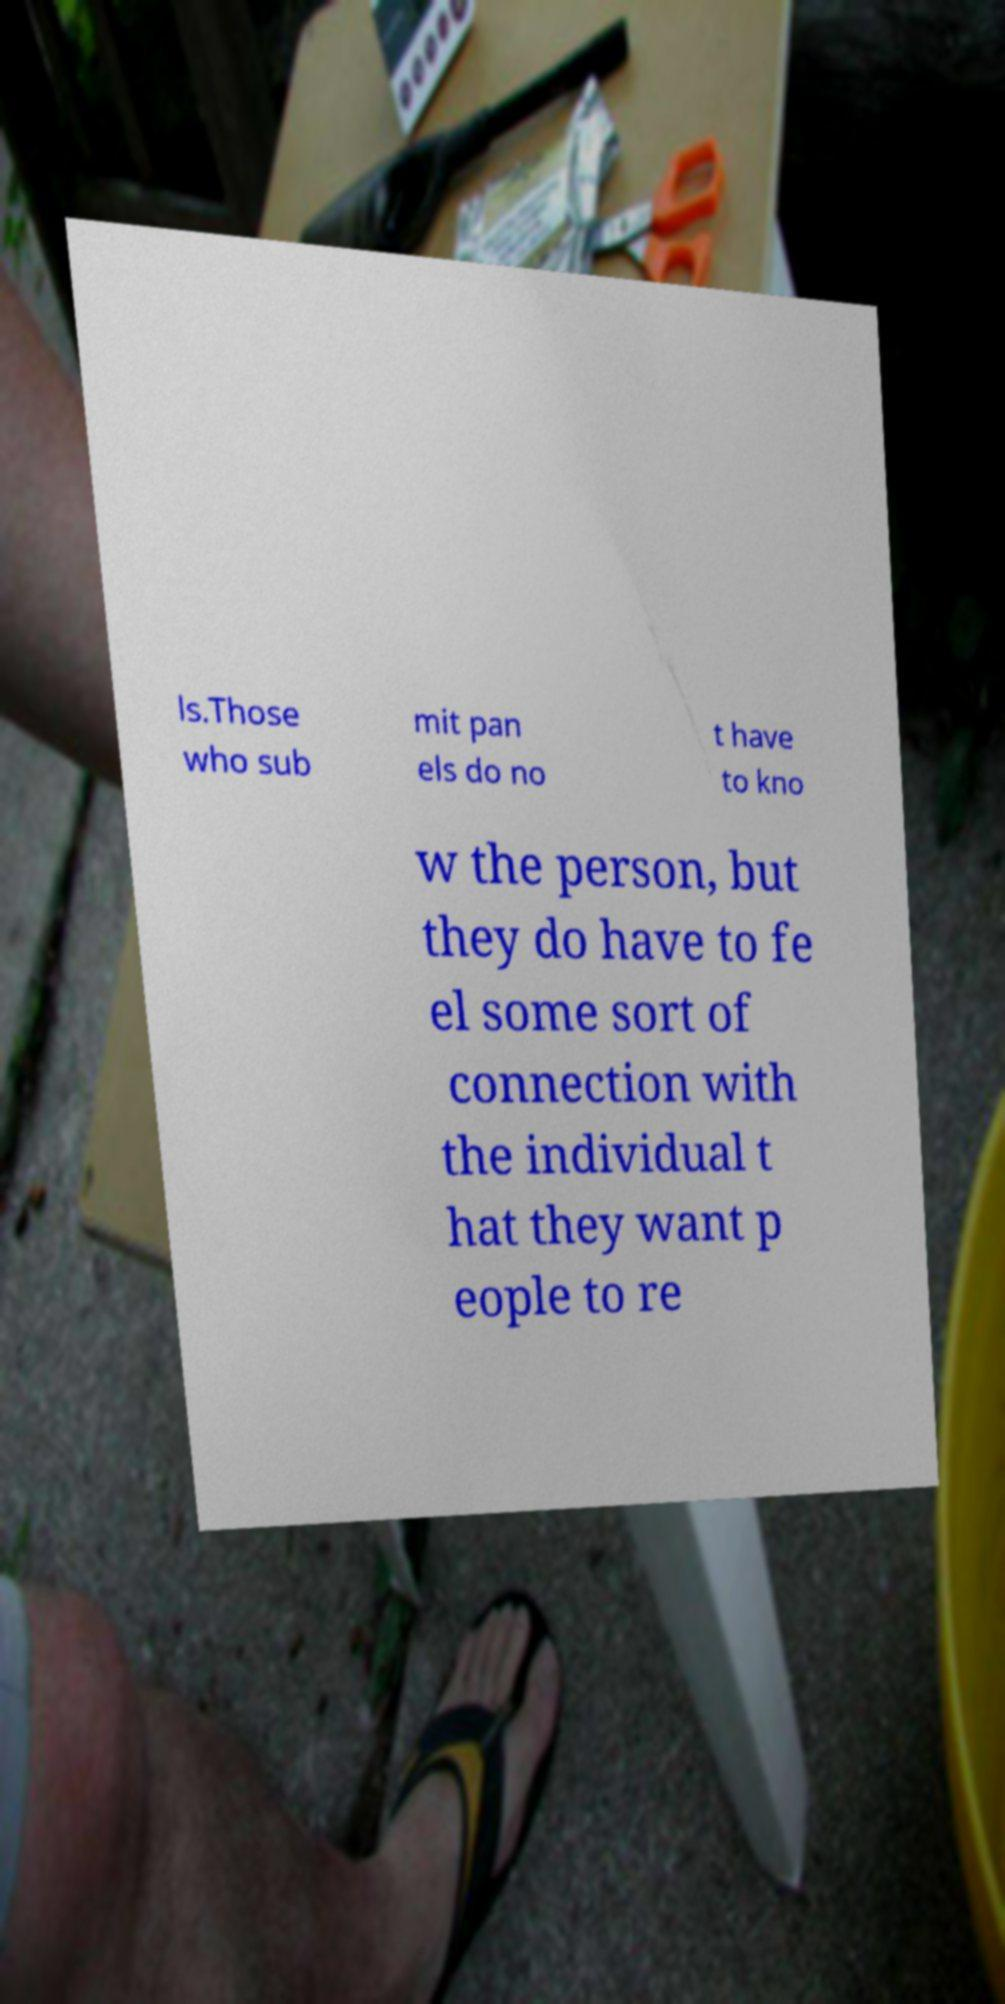Could you assist in decoding the text presented in this image and type it out clearly? ls.Those who sub mit pan els do no t have to kno w the person, but they do have to fe el some sort of connection with the individual t hat they want p eople to re 